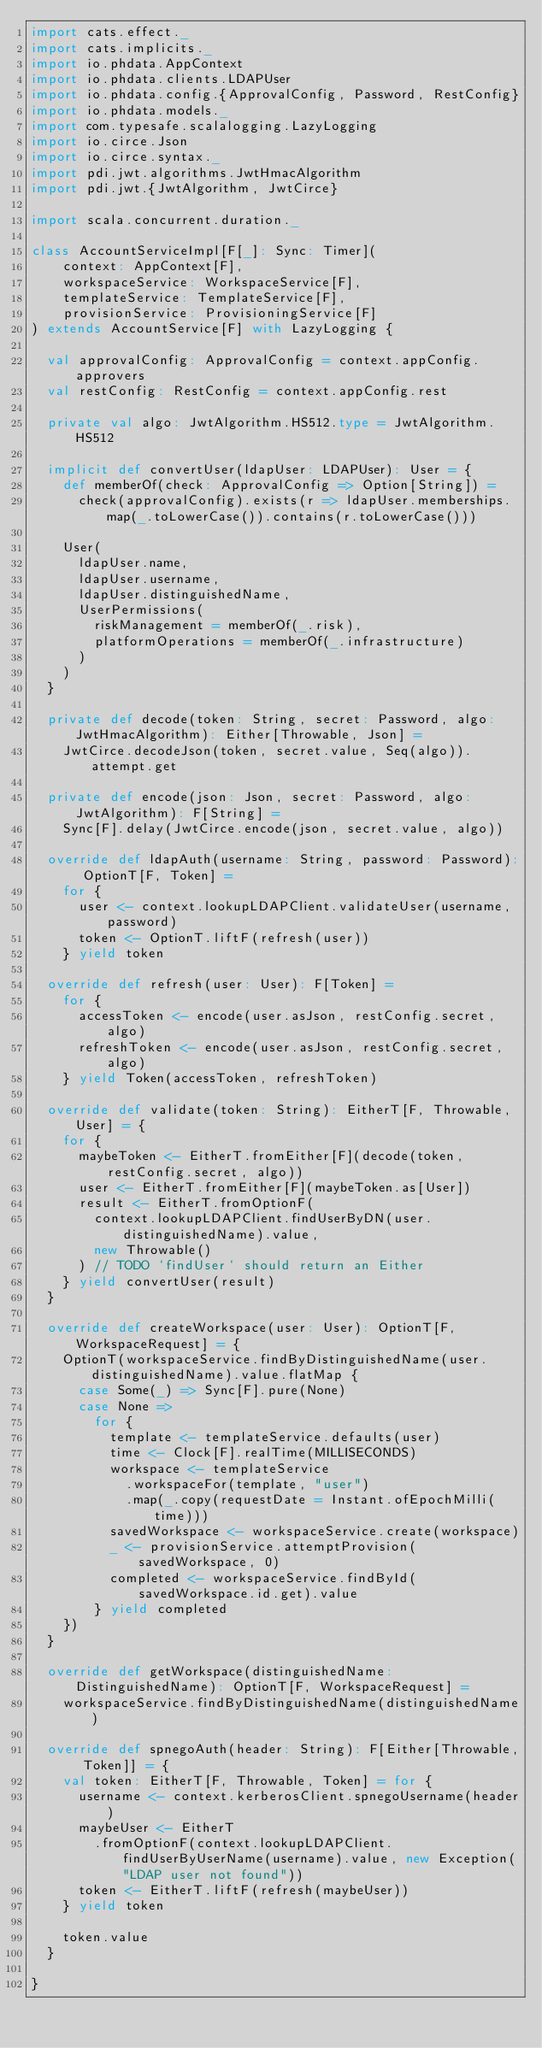Convert code to text. <code><loc_0><loc_0><loc_500><loc_500><_Scala_>import cats.effect._
import cats.implicits._
import io.phdata.AppContext
import io.phdata.clients.LDAPUser
import io.phdata.config.{ApprovalConfig, Password, RestConfig}
import io.phdata.models._
import com.typesafe.scalalogging.LazyLogging
import io.circe.Json
import io.circe.syntax._
import pdi.jwt.algorithms.JwtHmacAlgorithm
import pdi.jwt.{JwtAlgorithm, JwtCirce}

import scala.concurrent.duration._

class AccountServiceImpl[F[_]: Sync: Timer](
    context: AppContext[F],
    workspaceService: WorkspaceService[F],
    templateService: TemplateService[F],
    provisionService: ProvisioningService[F]
) extends AccountService[F] with LazyLogging {

  val approvalConfig: ApprovalConfig = context.appConfig.approvers
  val restConfig: RestConfig = context.appConfig.rest

  private val algo: JwtAlgorithm.HS512.type = JwtAlgorithm.HS512

  implicit def convertUser(ldapUser: LDAPUser): User = {
    def memberOf(check: ApprovalConfig => Option[String]) =
      check(approvalConfig).exists(r => ldapUser.memberships.map(_.toLowerCase()).contains(r.toLowerCase()))

    User(
      ldapUser.name,
      ldapUser.username,
      ldapUser.distinguishedName,
      UserPermissions(
        riskManagement = memberOf(_.risk),
        platformOperations = memberOf(_.infrastructure)
      )
    )
  }

  private def decode(token: String, secret: Password, algo: JwtHmacAlgorithm): Either[Throwable, Json] =
    JwtCirce.decodeJson(token, secret.value, Seq(algo)).attempt.get

  private def encode(json: Json, secret: Password, algo: JwtAlgorithm): F[String] =
    Sync[F].delay(JwtCirce.encode(json, secret.value, algo))

  override def ldapAuth(username: String, password: Password): OptionT[F, Token] =
    for {
      user <- context.lookupLDAPClient.validateUser(username, password)
      token <- OptionT.liftF(refresh(user))
    } yield token

  override def refresh(user: User): F[Token] =
    for {
      accessToken <- encode(user.asJson, restConfig.secret, algo)
      refreshToken <- encode(user.asJson, restConfig.secret, algo)
    } yield Token(accessToken, refreshToken)

  override def validate(token: String): EitherT[F, Throwable, User] = {
    for {
      maybeToken <- EitherT.fromEither[F](decode(token, restConfig.secret, algo))
      user <- EitherT.fromEither[F](maybeToken.as[User])
      result <- EitherT.fromOptionF(
        context.lookupLDAPClient.findUserByDN(user.distinguishedName).value,
        new Throwable()
      ) // TODO `findUser` should return an Either
    } yield convertUser(result)
  }

  override def createWorkspace(user: User): OptionT[F, WorkspaceRequest] = {
    OptionT(workspaceService.findByDistinguishedName(user.distinguishedName).value.flatMap {
      case Some(_) => Sync[F].pure(None)
      case None =>
        for {
          template <- templateService.defaults(user)
          time <- Clock[F].realTime(MILLISECONDS)
          workspace <- templateService
            .workspaceFor(template, "user")
            .map(_.copy(requestDate = Instant.ofEpochMilli(time)))
          savedWorkspace <- workspaceService.create(workspace)
          _ <- provisionService.attemptProvision(savedWorkspace, 0)
          completed <- workspaceService.findById(savedWorkspace.id.get).value
        } yield completed
    })
  }

  override def getWorkspace(distinguishedName: DistinguishedName): OptionT[F, WorkspaceRequest] =
    workspaceService.findByDistinguishedName(distinguishedName)

  override def spnegoAuth(header: String): F[Either[Throwable, Token]] = {
    val token: EitherT[F, Throwable, Token] = for {
      username <- context.kerberosClient.spnegoUsername(header)
      maybeUser <- EitherT
        .fromOptionF(context.lookupLDAPClient.findUserByUserName(username).value, new Exception("LDAP user not found"))
      token <- EitherT.liftF(refresh(maybeUser))
    } yield token

    token.value
  }

}
</code> 